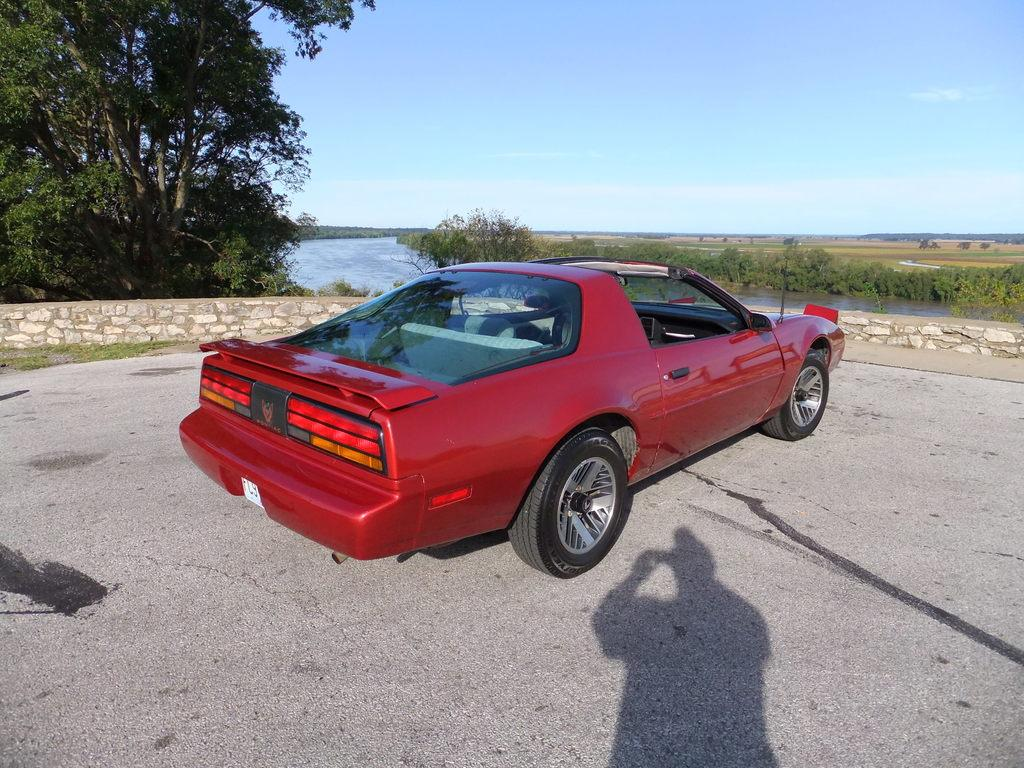What is the main subject of the image? The main subject of the image is a car. What colors can be seen on the car? The car is red and black in color. Where is the car located in the image? The car is on the ground. What can be seen in the background of the image? There are trees, water, and the sky visible in the background of the image. What color are the trees in the background? The trees are green in color. Is the ground visible in the image? Yes, the ground is visible in the image. What type of fang can be seen in the image? There is no fang present in the image. How many crows are visible in the image? There are no crows present in the image. 